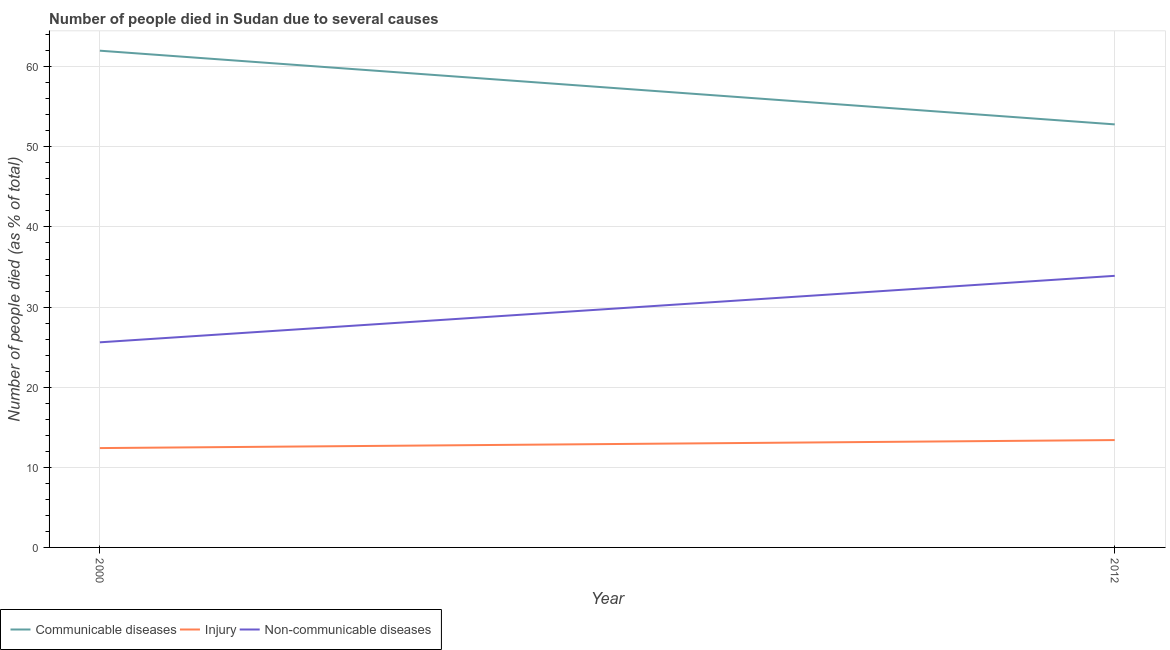Does the line corresponding to number of people who dies of non-communicable diseases intersect with the line corresponding to number of people who died of communicable diseases?
Keep it short and to the point. No. What is the number of people who dies of non-communicable diseases in 2012?
Ensure brevity in your answer.  33.9. Across all years, what is the maximum number of people who dies of non-communicable diseases?
Provide a short and direct response. 33.9. Across all years, what is the minimum number of people who died of injury?
Offer a very short reply. 12.4. In which year was the number of people who died of communicable diseases maximum?
Make the answer very short. 2000. In which year was the number of people who died of communicable diseases minimum?
Offer a very short reply. 2012. What is the total number of people who died of communicable diseases in the graph?
Give a very brief answer. 114.8. What is the difference between the number of people who dies of non-communicable diseases in 2000 and that in 2012?
Ensure brevity in your answer.  -8.3. What is the difference between the number of people who died of communicable diseases in 2012 and the number of people who dies of non-communicable diseases in 2000?
Provide a short and direct response. 27.2. What is the average number of people who died of communicable diseases per year?
Your response must be concise. 57.4. In the year 2000, what is the difference between the number of people who dies of non-communicable diseases and number of people who died of communicable diseases?
Give a very brief answer. -36.4. In how many years, is the number of people who died of communicable diseases greater than 30 %?
Provide a succinct answer. 2. What is the ratio of the number of people who died of injury in 2000 to that in 2012?
Your answer should be compact. 0.93. Is it the case that in every year, the sum of the number of people who died of communicable diseases and number of people who died of injury is greater than the number of people who dies of non-communicable diseases?
Offer a very short reply. Yes. How many lines are there?
Provide a succinct answer. 3. How many years are there in the graph?
Give a very brief answer. 2. What is the difference between two consecutive major ticks on the Y-axis?
Offer a terse response. 10. Does the graph contain any zero values?
Provide a short and direct response. No. Does the graph contain grids?
Give a very brief answer. Yes. Where does the legend appear in the graph?
Make the answer very short. Bottom left. How many legend labels are there?
Give a very brief answer. 3. How are the legend labels stacked?
Keep it short and to the point. Horizontal. What is the title of the graph?
Give a very brief answer. Number of people died in Sudan due to several causes. Does "Ages 50+" appear as one of the legend labels in the graph?
Your answer should be very brief. No. What is the label or title of the Y-axis?
Keep it short and to the point. Number of people died (as % of total). What is the Number of people died (as % of total) in Communicable diseases in 2000?
Your answer should be compact. 62. What is the Number of people died (as % of total) of Non-communicable diseases in 2000?
Ensure brevity in your answer.  25.6. What is the Number of people died (as % of total) in Communicable diseases in 2012?
Your answer should be very brief. 52.8. What is the Number of people died (as % of total) of Non-communicable diseases in 2012?
Your response must be concise. 33.9. Across all years, what is the maximum Number of people died (as % of total) in Injury?
Your answer should be very brief. 13.4. Across all years, what is the maximum Number of people died (as % of total) in Non-communicable diseases?
Your response must be concise. 33.9. Across all years, what is the minimum Number of people died (as % of total) of Communicable diseases?
Make the answer very short. 52.8. Across all years, what is the minimum Number of people died (as % of total) of Injury?
Make the answer very short. 12.4. Across all years, what is the minimum Number of people died (as % of total) in Non-communicable diseases?
Your answer should be very brief. 25.6. What is the total Number of people died (as % of total) in Communicable diseases in the graph?
Keep it short and to the point. 114.8. What is the total Number of people died (as % of total) in Injury in the graph?
Provide a short and direct response. 25.8. What is the total Number of people died (as % of total) in Non-communicable diseases in the graph?
Keep it short and to the point. 59.5. What is the difference between the Number of people died (as % of total) of Communicable diseases in 2000 and that in 2012?
Offer a very short reply. 9.2. What is the difference between the Number of people died (as % of total) in Communicable diseases in 2000 and the Number of people died (as % of total) in Injury in 2012?
Give a very brief answer. 48.6. What is the difference between the Number of people died (as % of total) of Communicable diseases in 2000 and the Number of people died (as % of total) of Non-communicable diseases in 2012?
Provide a succinct answer. 28.1. What is the difference between the Number of people died (as % of total) in Injury in 2000 and the Number of people died (as % of total) in Non-communicable diseases in 2012?
Make the answer very short. -21.5. What is the average Number of people died (as % of total) of Communicable diseases per year?
Offer a terse response. 57.4. What is the average Number of people died (as % of total) of Injury per year?
Your response must be concise. 12.9. What is the average Number of people died (as % of total) in Non-communicable diseases per year?
Keep it short and to the point. 29.75. In the year 2000, what is the difference between the Number of people died (as % of total) in Communicable diseases and Number of people died (as % of total) in Injury?
Keep it short and to the point. 49.6. In the year 2000, what is the difference between the Number of people died (as % of total) of Communicable diseases and Number of people died (as % of total) of Non-communicable diseases?
Offer a terse response. 36.4. In the year 2012, what is the difference between the Number of people died (as % of total) in Communicable diseases and Number of people died (as % of total) in Injury?
Provide a short and direct response. 39.4. In the year 2012, what is the difference between the Number of people died (as % of total) of Communicable diseases and Number of people died (as % of total) of Non-communicable diseases?
Provide a short and direct response. 18.9. In the year 2012, what is the difference between the Number of people died (as % of total) in Injury and Number of people died (as % of total) in Non-communicable diseases?
Your answer should be compact. -20.5. What is the ratio of the Number of people died (as % of total) of Communicable diseases in 2000 to that in 2012?
Provide a succinct answer. 1.17. What is the ratio of the Number of people died (as % of total) of Injury in 2000 to that in 2012?
Offer a very short reply. 0.93. What is the ratio of the Number of people died (as % of total) in Non-communicable diseases in 2000 to that in 2012?
Your response must be concise. 0.76. What is the difference between the highest and the second highest Number of people died (as % of total) in Non-communicable diseases?
Your answer should be compact. 8.3. What is the difference between the highest and the lowest Number of people died (as % of total) of Communicable diseases?
Your answer should be compact. 9.2. What is the difference between the highest and the lowest Number of people died (as % of total) of Injury?
Your answer should be compact. 1. 